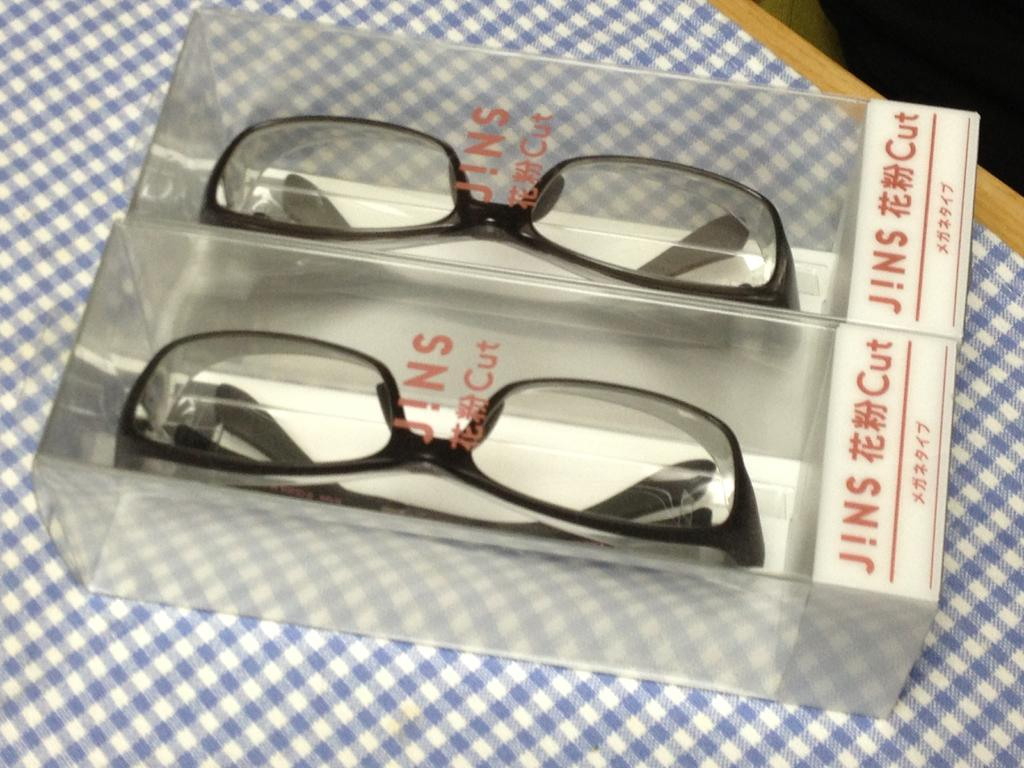What objects are in the boxes in the image? There are spectacles in the boxes in the image. What is on the platform in the image? There is cloth on a platform in the image. How many thumbs are visible on the platform in the image? There are no thumbs visible on the platform in the image. What type of crate is used to store the spectacles in the image? There is no crate present in the image; the spectacles are in boxes. 